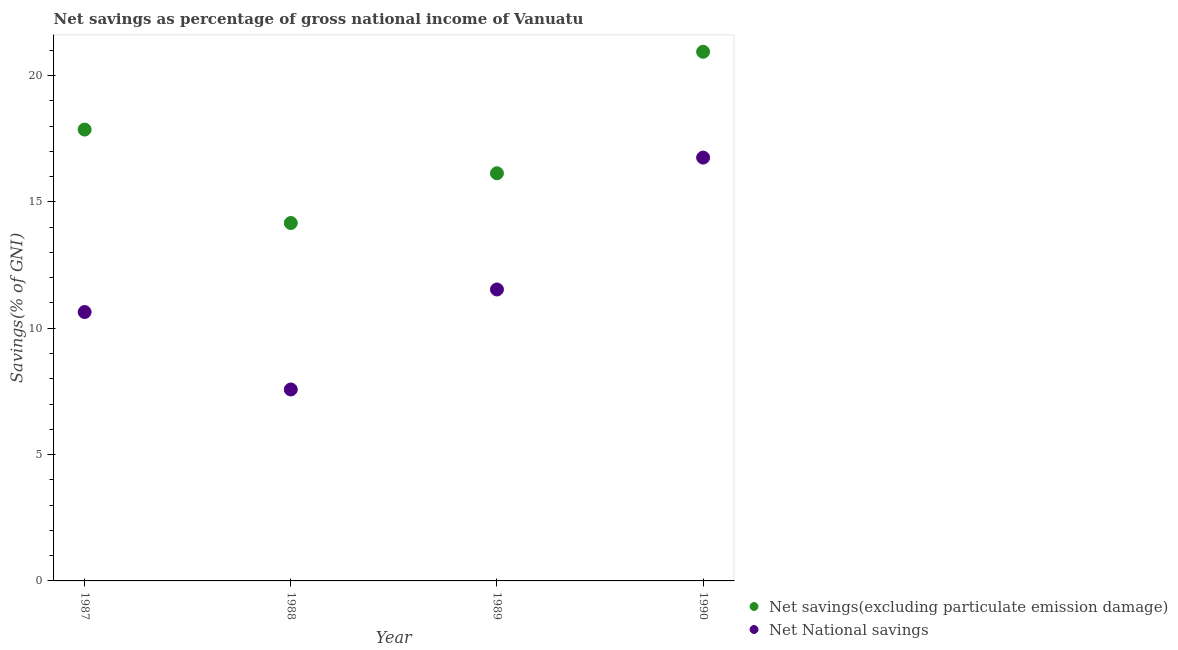How many different coloured dotlines are there?
Make the answer very short. 2. What is the net national savings in 1988?
Ensure brevity in your answer.  7.58. Across all years, what is the maximum net national savings?
Provide a succinct answer. 16.75. Across all years, what is the minimum net national savings?
Your response must be concise. 7.58. What is the total net national savings in the graph?
Your answer should be compact. 46.51. What is the difference between the net national savings in 1987 and that in 1990?
Provide a short and direct response. -6.11. What is the difference between the net savings(excluding particulate emission damage) in 1989 and the net national savings in 1990?
Your response must be concise. -0.62. What is the average net national savings per year?
Provide a short and direct response. 11.63. In the year 1989, what is the difference between the net national savings and net savings(excluding particulate emission damage)?
Provide a succinct answer. -4.6. What is the ratio of the net national savings in 1987 to that in 1990?
Provide a short and direct response. 0.64. Is the net national savings in 1987 less than that in 1989?
Offer a terse response. Yes. Is the difference between the net national savings in 1987 and 1988 greater than the difference between the net savings(excluding particulate emission damage) in 1987 and 1988?
Your answer should be compact. No. What is the difference between the highest and the second highest net savings(excluding particulate emission damage)?
Provide a short and direct response. 3.08. What is the difference between the highest and the lowest net national savings?
Ensure brevity in your answer.  9.18. In how many years, is the net savings(excluding particulate emission damage) greater than the average net savings(excluding particulate emission damage) taken over all years?
Offer a very short reply. 2. Is the sum of the net national savings in 1987 and 1990 greater than the maximum net savings(excluding particulate emission damage) across all years?
Offer a terse response. Yes. Is the net national savings strictly greater than the net savings(excluding particulate emission damage) over the years?
Offer a terse response. No. How many years are there in the graph?
Your answer should be very brief. 4. What is the difference between two consecutive major ticks on the Y-axis?
Make the answer very short. 5. Does the graph contain grids?
Give a very brief answer. No. Where does the legend appear in the graph?
Ensure brevity in your answer.  Bottom right. How are the legend labels stacked?
Make the answer very short. Vertical. What is the title of the graph?
Offer a very short reply. Net savings as percentage of gross national income of Vanuatu. Does "Electricity" appear as one of the legend labels in the graph?
Ensure brevity in your answer.  No. What is the label or title of the Y-axis?
Offer a terse response. Savings(% of GNI). What is the Savings(% of GNI) of Net savings(excluding particulate emission damage) in 1987?
Offer a terse response. 17.86. What is the Savings(% of GNI) in Net National savings in 1987?
Provide a short and direct response. 10.64. What is the Savings(% of GNI) of Net savings(excluding particulate emission damage) in 1988?
Make the answer very short. 14.16. What is the Savings(% of GNI) in Net National savings in 1988?
Your response must be concise. 7.58. What is the Savings(% of GNI) in Net savings(excluding particulate emission damage) in 1989?
Make the answer very short. 16.13. What is the Savings(% of GNI) of Net National savings in 1989?
Offer a terse response. 11.53. What is the Savings(% of GNI) of Net savings(excluding particulate emission damage) in 1990?
Keep it short and to the point. 20.94. What is the Savings(% of GNI) of Net National savings in 1990?
Provide a succinct answer. 16.75. Across all years, what is the maximum Savings(% of GNI) of Net savings(excluding particulate emission damage)?
Keep it short and to the point. 20.94. Across all years, what is the maximum Savings(% of GNI) in Net National savings?
Ensure brevity in your answer.  16.75. Across all years, what is the minimum Savings(% of GNI) of Net savings(excluding particulate emission damage)?
Ensure brevity in your answer.  14.16. Across all years, what is the minimum Savings(% of GNI) of Net National savings?
Offer a terse response. 7.58. What is the total Savings(% of GNI) in Net savings(excluding particulate emission damage) in the graph?
Ensure brevity in your answer.  69.1. What is the total Savings(% of GNI) of Net National savings in the graph?
Offer a very short reply. 46.51. What is the difference between the Savings(% of GNI) of Net savings(excluding particulate emission damage) in 1987 and that in 1988?
Your answer should be compact. 3.7. What is the difference between the Savings(% of GNI) of Net National savings in 1987 and that in 1988?
Your response must be concise. 3.06. What is the difference between the Savings(% of GNI) in Net savings(excluding particulate emission damage) in 1987 and that in 1989?
Keep it short and to the point. 1.73. What is the difference between the Savings(% of GNI) in Net National savings in 1987 and that in 1989?
Provide a short and direct response. -0.89. What is the difference between the Savings(% of GNI) of Net savings(excluding particulate emission damage) in 1987 and that in 1990?
Ensure brevity in your answer.  -3.08. What is the difference between the Savings(% of GNI) of Net National savings in 1987 and that in 1990?
Ensure brevity in your answer.  -6.11. What is the difference between the Savings(% of GNI) of Net savings(excluding particulate emission damage) in 1988 and that in 1989?
Provide a short and direct response. -1.97. What is the difference between the Savings(% of GNI) in Net National savings in 1988 and that in 1989?
Make the answer very short. -3.96. What is the difference between the Savings(% of GNI) of Net savings(excluding particulate emission damage) in 1988 and that in 1990?
Give a very brief answer. -6.78. What is the difference between the Savings(% of GNI) in Net National savings in 1988 and that in 1990?
Provide a short and direct response. -9.18. What is the difference between the Savings(% of GNI) in Net savings(excluding particulate emission damage) in 1989 and that in 1990?
Offer a terse response. -4.81. What is the difference between the Savings(% of GNI) of Net National savings in 1989 and that in 1990?
Ensure brevity in your answer.  -5.22. What is the difference between the Savings(% of GNI) in Net savings(excluding particulate emission damage) in 1987 and the Savings(% of GNI) in Net National savings in 1988?
Your answer should be very brief. 10.29. What is the difference between the Savings(% of GNI) of Net savings(excluding particulate emission damage) in 1987 and the Savings(% of GNI) of Net National savings in 1989?
Your answer should be very brief. 6.33. What is the difference between the Savings(% of GNI) of Net savings(excluding particulate emission damage) in 1987 and the Savings(% of GNI) of Net National savings in 1990?
Your answer should be compact. 1.11. What is the difference between the Savings(% of GNI) in Net savings(excluding particulate emission damage) in 1988 and the Savings(% of GNI) in Net National savings in 1989?
Provide a short and direct response. 2.63. What is the difference between the Savings(% of GNI) in Net savings(excluding particulate emission damage) in 1988 and the Savings(% of GNI) in Net National savings in 1990?
Offer a very short reply. -2.59. What is the difference between the Savings(% of GNI) of Net savings(excluding particulate emission damage) in 1989 and the Savings(% of GNI) of Net National savings in 1990?
Your answer should be very brief. -0.62. What is the average Savings(% of GNI) of Net savings(excluding particulate emission damage) per year?
Your answer should be compact. 17.28. What is the average Savings(% of GNI) of Net National savings per year?
Give a very brief answer. 11.63. In the year 1987, what is the difference between the Savings(% of GNI) in Net savings(excluding particulate emission damage) and Savings(% of GNI) in Net National savings?
Offer a very short reply. 7.22. In the year 1988, what is the difference between the Savings(% of GNI) in Net savings(excluding particulate emission damage) and Savings(% of GNI) in Net National savings?
Offer a very short reply. 6.59. In the year 1989, what is the difference between the Savings(% of GNI) of Net savings(excluding particulate emission damage) and Savings(% of GNI) of Net National savings?
Your answer should be very brief. 4.6. In the year 1990, what is the difference between the Savings(% of GNI) of Net savings(excluding particulate emission damage) and Savings(% of GNI) of Net National savings?
Offer a terse response. 4.19. What is the ratio of the Savings(% of GNI) in Net savings(excluding particulate emission damage) in 1987 to that in 1988?
Keep it short and to the point. 1.26. What is the ratio of the Savings(% of GNI) of Net National savings in 1987 to that in 1988?
Your answer should be compact. 1.4. What is the ratio of the Savings(% of GNI) in Net savings(excluding particulate emission damage) in 1987 to that in 1989?
Ensure brevity in your answer.  1.11. What is the ratio of the Savings(% of GNI) in Net National savings in 1987 to that in 1989?
Your answer should be compact. 0.92. What is the ratio of the Savings(% of GNI) of Net savings(excluding particulate emission damage) in 1987 to that in 1990?
Ensure brevity in your answer.  0.85. What is the ratio of the Savings(% of GNI) in Net National savings in 1987 to that in 1990?
Provide a short and direct response. 0.64. What is the ratio of the Savings(% of GNI) of Net savings(excluding particulate emission damage) in 1988 to that in 1989?
Your answer should be compact. 0.88. What is the ratio of the Savings(% of GNI) of Net National savings in 1988 to that in 1989?
Give a very brief answer. 0.66. What is the ratio of the Savings(% of GNI) of Net savings(excluding particulate emission damage) in 1988 to that in 1990?
Your answer should be very brief. 0.68. What is the ratio of the Savings(% of GNI) of Net National savings in 1988 to that in 1990?
Make the answer very short. 0.45. What is the ratio of the Savings(% of GNI) of Net savings(excluding particulate emission damage) in 1989 to that in 1990?
Keep it short and to the point. 0.77. What is the ratio of the Savings(% of GNI) in Net National savings in 1989 to that in 1990?
Provide a short and direct response. 0.69. What is the difference between the highest and the second highest Savings(% of GNI) in Net savings(excluding particulate emission damage)?
Give a very brief answer. 3.08. What is the difference between the highest and the second highest Savings(% of GNI) in Net National savings?
Offer a terse response. 5.22. What is the difference between the highest and the lowest Savings(% of GNI) in Net savings(excluding particulate emission damage)?
Ensure brevity in your answer.  6.78. What is the difference between the highest and the lowest Savings(% of GNI) in Net National savings?
Your answer should be very brief. 9.18. 